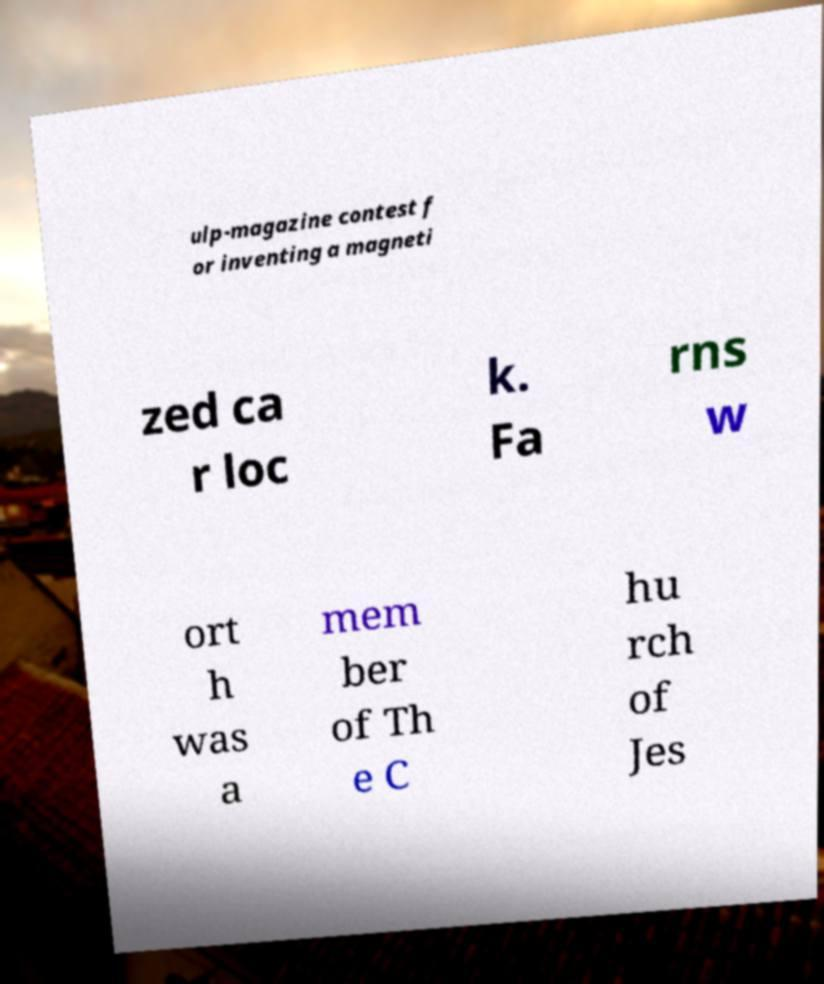Can you read and provide the text displayed in the image?This photo seems to have some interesting text. Can you extract and type it out for me? ulp-magazine contest f or inventing a magneti zed ca r loc k. Fa rns w ort h was a mem ber of Th e C hu rch of Jes 